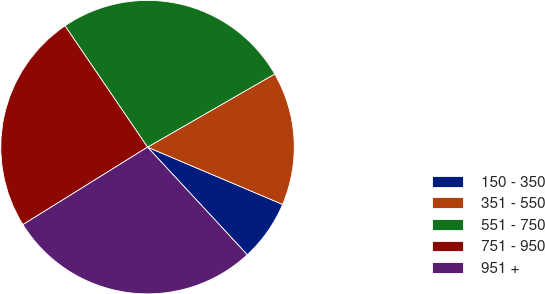Convert chart to OTSL. <chart><loc_0><loc_0><loc_500><loc_500><pie_chart><fcel>150 - 350<fcel>351 - 550<fcel>551 - 750<fcel>751 - 950<fcel>951 +<nl><fcel>6.72%<fcel>14.69%<fcel>26.2%<fcel>24.35%<fcel>28.04%<nl></chart> 